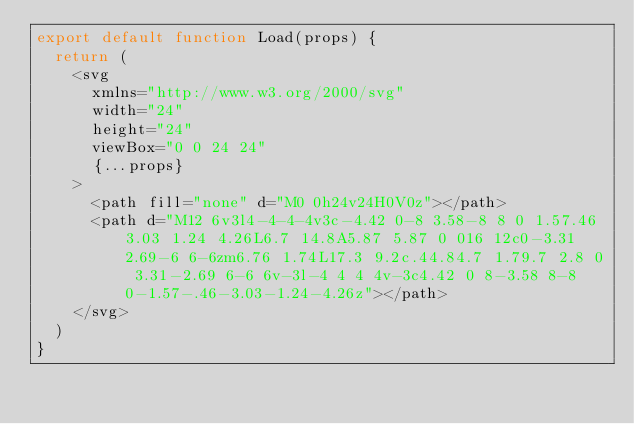<code> <loc_0><loc_0><loc_500><loc_500><_JavaScript_>export default function Load(props) {
  return (
    <svg
      xmlns="http://www.w3.org/2000/svg"
      width="24"
      height="24"
      viewBox="0 0 24 24"
      {...props}
    >
      <path fill="none" d="M0 0h24v24H0V0z"></path>
      <path d="M12 6v3l4-4-4-4v3c-4.42 0-8 3.58-8 8 0 1.57.46 3.03 1.24 4.26L6.7 14.8A5.87 5.87 0 016 12c0-3.31 2.69-6 6-6zm6.76 1.74L17.3 9.2c.44.84.7 1.79.7 2.8 0 3.31-2.69 6-6 6v-3l-4 4 4 4v-3c4.42 0 8-3.58 8-8 0-1.57-.46-3.03-1.24-4.26z"></path>
    </svg>
  )
}
</code> 